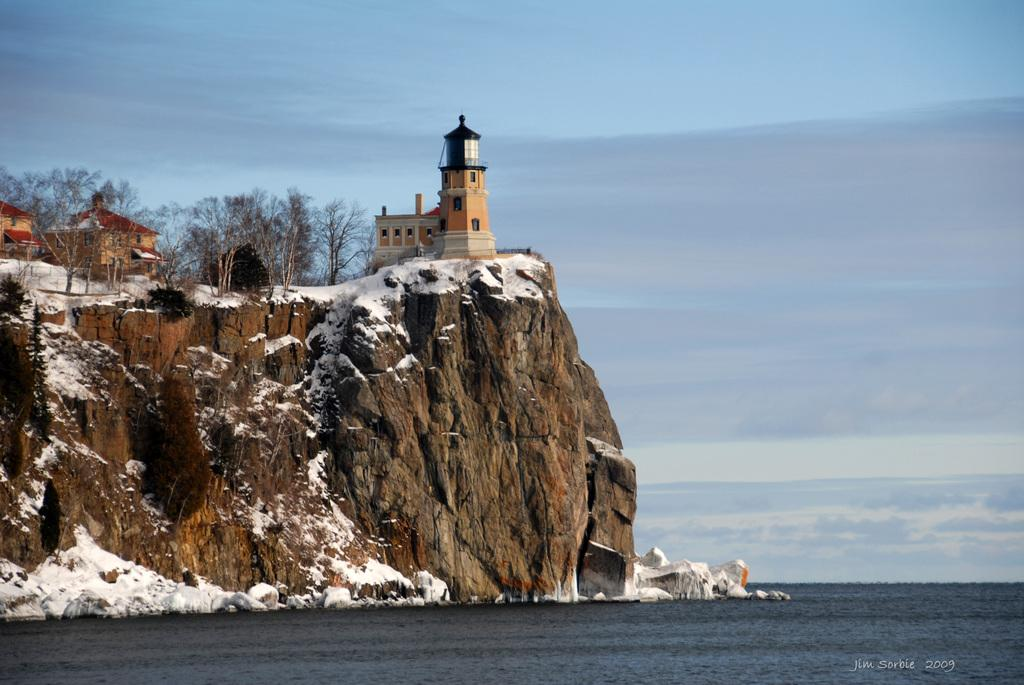What type of vegetation is on the left side of the image? There are trees on the left side of the image. What can be seen on the mountain in the image? There are buildings on a mountain in the image. What is the condition of the mountain in the image? The mountain is covered with snow. What is visible at the bottom of the image? There is water visible at the bottom of the image. Can you spot the trick base in the image? There is no trick base present in the image. What type of animals might be using the base in the image? There is no base or animals present in the image. 